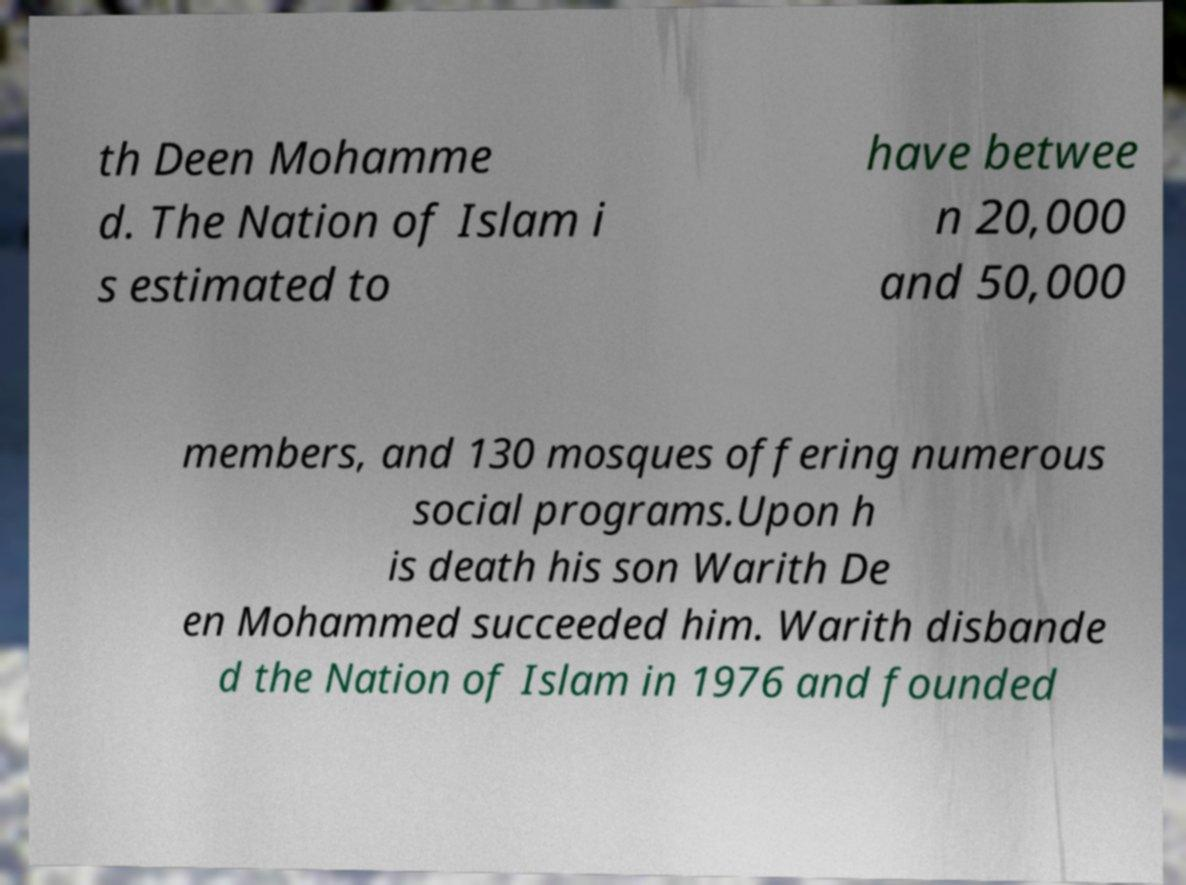Can you read and provide the text displayed in the image?This photo seems to have some interesting text. Can you extract and type it out for me? th Deen Mohamme d. The Nation of Islam i s estimated to have betwee n 20,000 and 50,000 members, and 130 mosques offering numerous social programs.Upon h is death his son Warith De en Mohammed succeeded him. Warith disbande d the Nation of Islam in 1976 and founded 